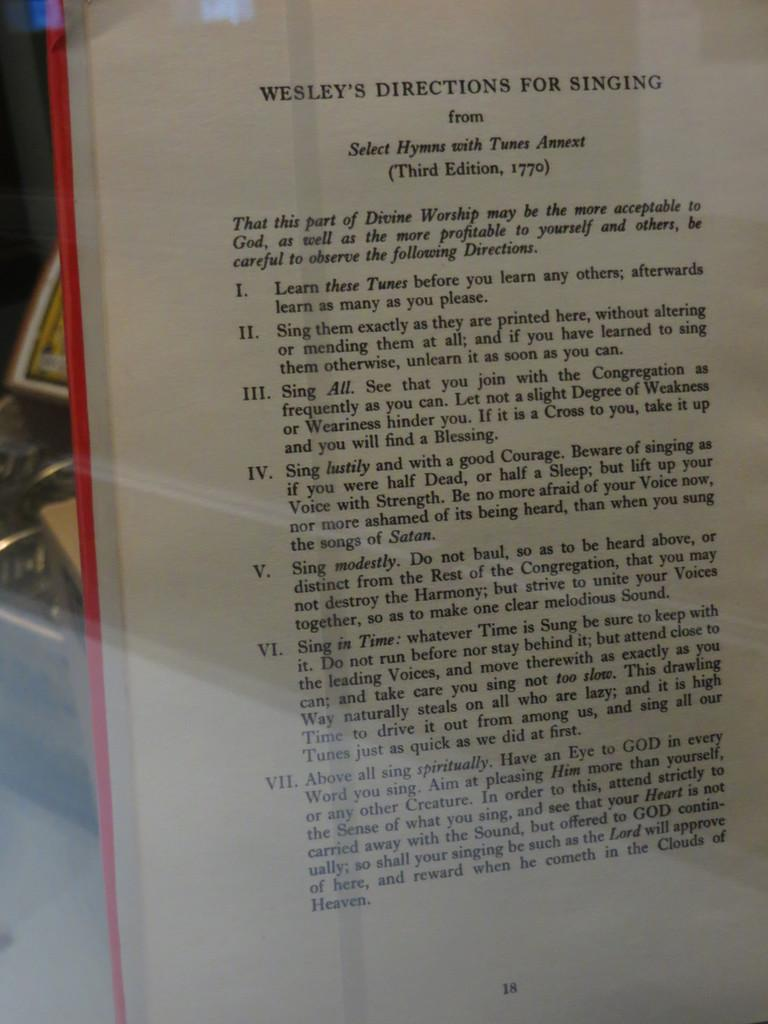<image>
Relay a brief, clear account of the picture shown. A book opened to a page called Wesley's directions for singing. 